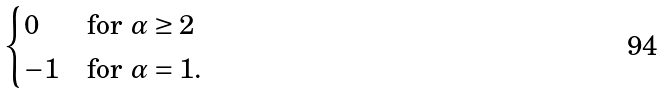Convert formula to latex. <formula><loc_0><loc_0><loc_500><loc_500>\begin{cases} 0 & \text {for $\alpha\geq 2$} \\ - 1 & \text {for $\alpha=1$.} \end{cases}</formula> 